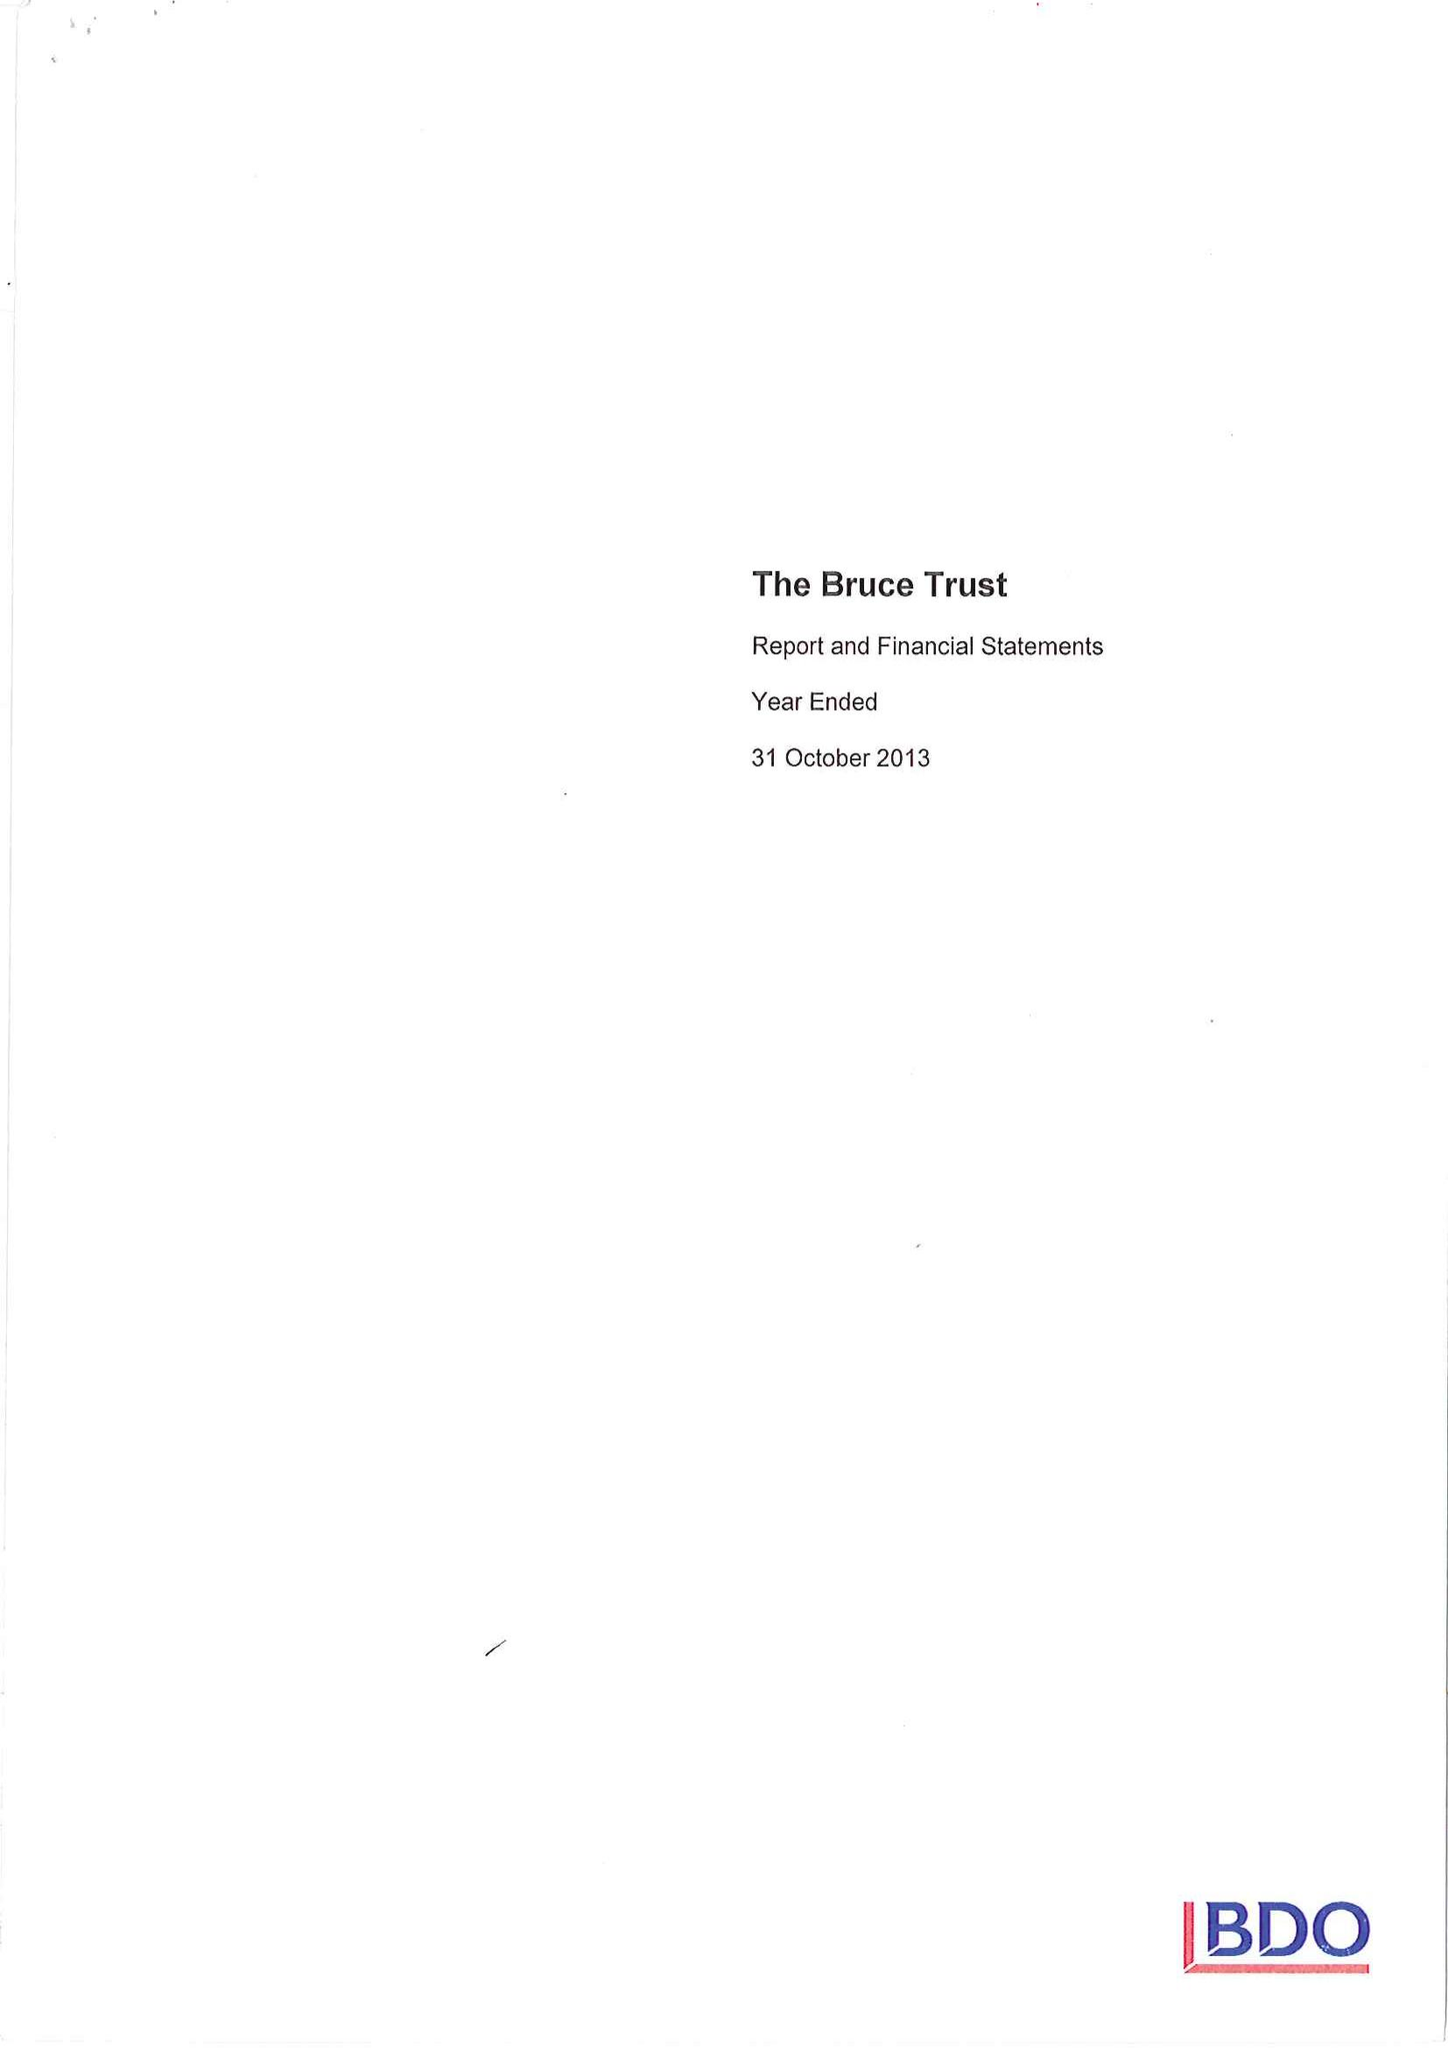What is the value for the charity_number?
Answer the question using a single word or phrase. 800402 